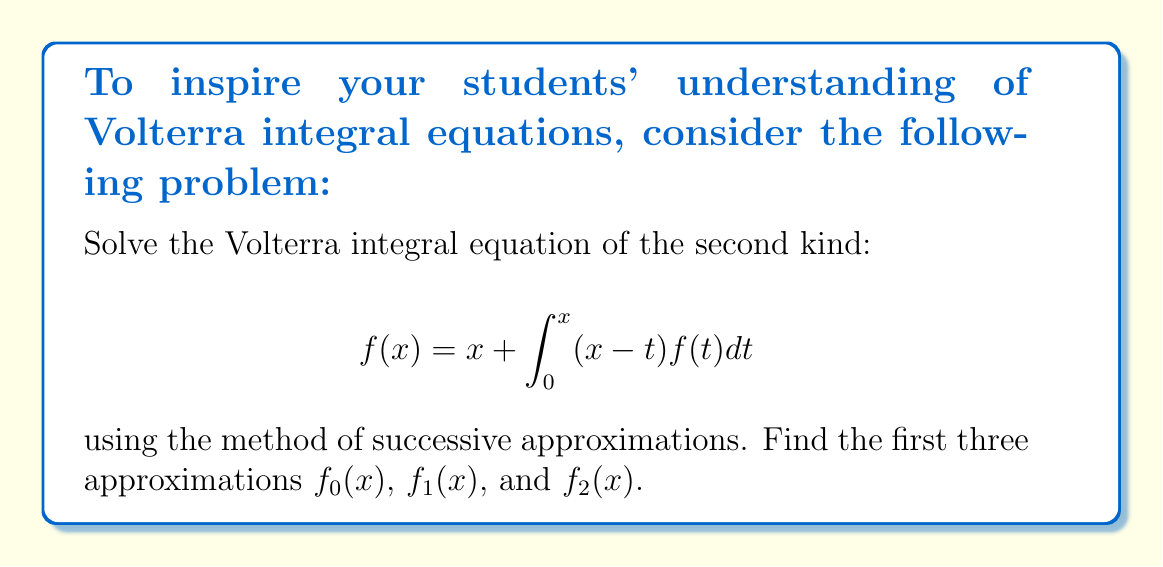What is the answer to this math problem? Let's solve this step-by-step using the method of successive approximations:

1) First, we set $f_0(x) = x$, which is the non-integral term in the equation.

2) For $f_1(x)$, we substitute $f_0(x)$ into the right-hand side of the equation:

   $$f_1(x) = x + \int_0^x (x-t)f_0(t)dt = x + \int_0^x (x-t)t dt$$

3) Evaluate the integral:
   
   $$f_1(x) = x + \left[xt^2/2 - t^3/3\right]_0^x = x + x^3/2 - x^3/3 = x + x^3/6$$

4) For $f_2(x)$, we substitute $f_1(x)$ into the right-hand side:

   $$f_2(x) = x + \int_0^x (x-t)(t + t^3/6)dt$$

5) Expand the integrand:

   $$f_2(x) = x + \int_0^x (xt + xt^3/6 - t^2 - t^4/6)dt$$

6) Evaluate the integral:

   $$f_2(x) = x + \left[xt^2/2 + xt^4/24 - t^3/3 - t^5/30\right]_0^x$$
   
   $$= x + x^3/2 + x^5/24 - x^3/3 - x^5/30$$
   
   $$= x + x^3/6 + x^5/40$$

Therefore, the first three approximations are:

$f_0(x) = x$
$f_1(x) = x + x^3/6$
$f_2(x) = x + x^3/6 + x^5/40$
Answer: $f_0(x) = x$, $f_1(x) = x + \frac{x^3}{6}$, $f_2(x) = x + \frac{x^3}{6} + \frac{x^5}{40}$ 